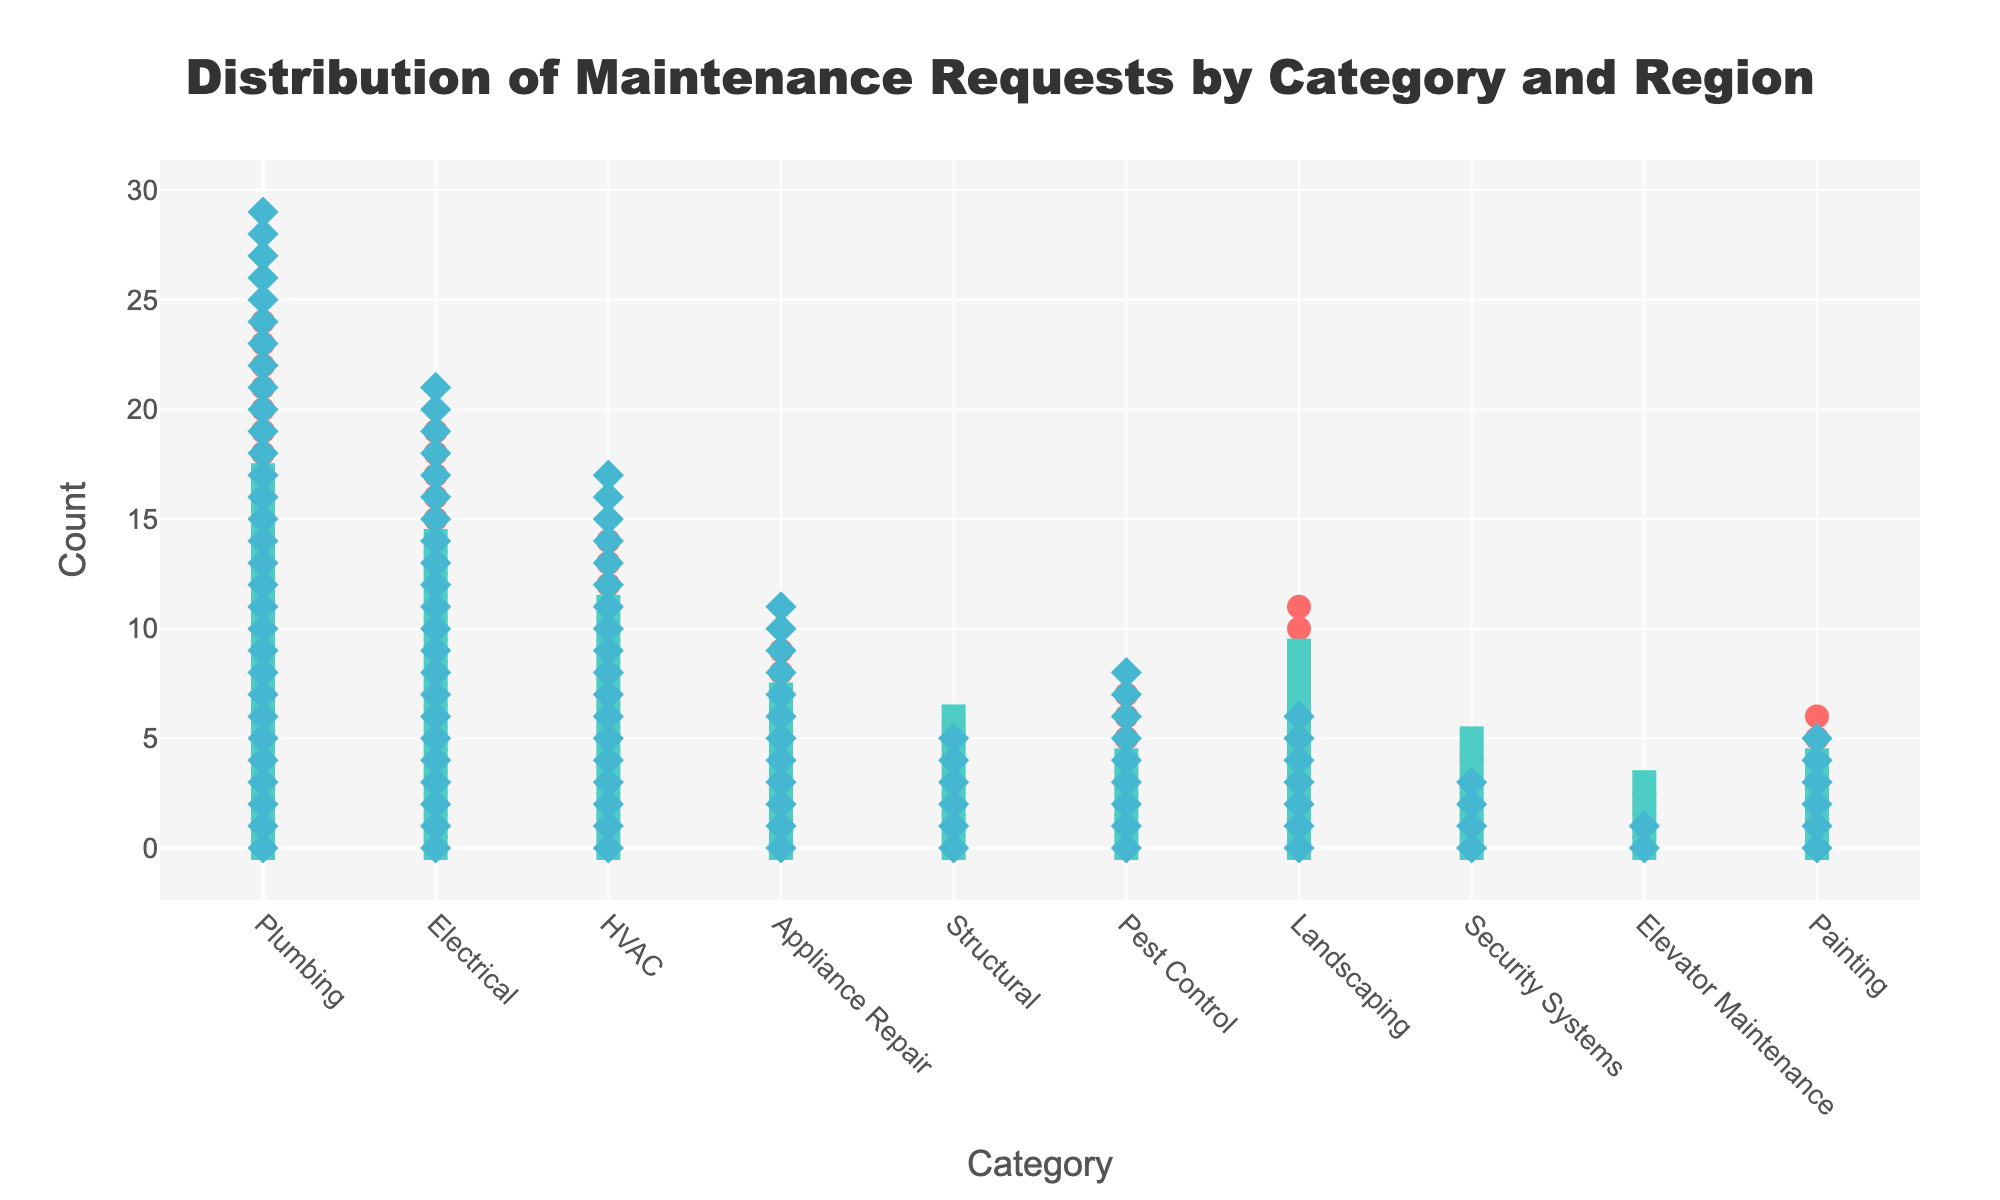What is the category with the highest number of maintenance requests in North America? Look for the category with the highest count of markers in the North American region. Plumbing has the most markers with 25 requests.
Answer: Plumbing Which region has the fewest maintenance requests for Elevator Maintenance? Compare the count of markers for Elevator Maintenance in each region. Asia Pacific has the fewest with 2 requests.
Answer: Asia Pacific How many more Plumbing requests are there in Asia Pacific compared to Europe? Find the counts of Plumbing requests in both regions: Asia Pacific has 30 and Europe has 18. Calculate the difference: 30 - 18 = 12.
Answer: 12 What is the total number of Painting requests across all regions? Sum the counts of Painting requests in each region: North America has 7, Europe has 5, and Asia Pacific has 6. Total: 7 + 5 + 6 = 18.
Answer: 18 In which category does Europe have more requests than North America? Compare the counts for each category between Europe and North America. Structural is the only category where Europe (7) has more requests than North America (5).
Answer: Structural Which region has the highest total number of maintenance requests? Sum the counts for all categories in each region. North America: 25+20+15+10+5+8+12+5+3+7 = 110, Europe: 18+15+12+8+7+5+10+6+4+5 = 90, Asia Pacific: 30+22+18+12+6+9+7+4+2+6 = 116. Asia Pacific has the highest total with 116.
Answer: Asia Pacific What is the average number of Electrical requests across all regions? Sum the Electrical counts and divide by the number of regions: 20 (NA) + 15 (EU) + 22 (AP) = 57. Average: 57 / 3 = 19.
Answer: 19 Which category has the lowest maintenance requests in Europe? Look for the category with the fewest markers in the Europe region. Elevator Maintenance has the fewest with 4 requests.
Answer: Elevator Maintenance Are there more Landscaping or Pest Control requests in North America? By how many? Compare the counts for Landscaping (12) and Pest Control (8) in North America. Calculate the difference: 12 - 8 = 4.
Answer: Landscaping by 4 Which region has the most Appliance Repair requests? Compare the Appliance Repair counts across regions: North America (10), Europe (8), Asia Pacific (12). Asia Pacific has the most with 12 requests.
Answer: Asia Pacific 